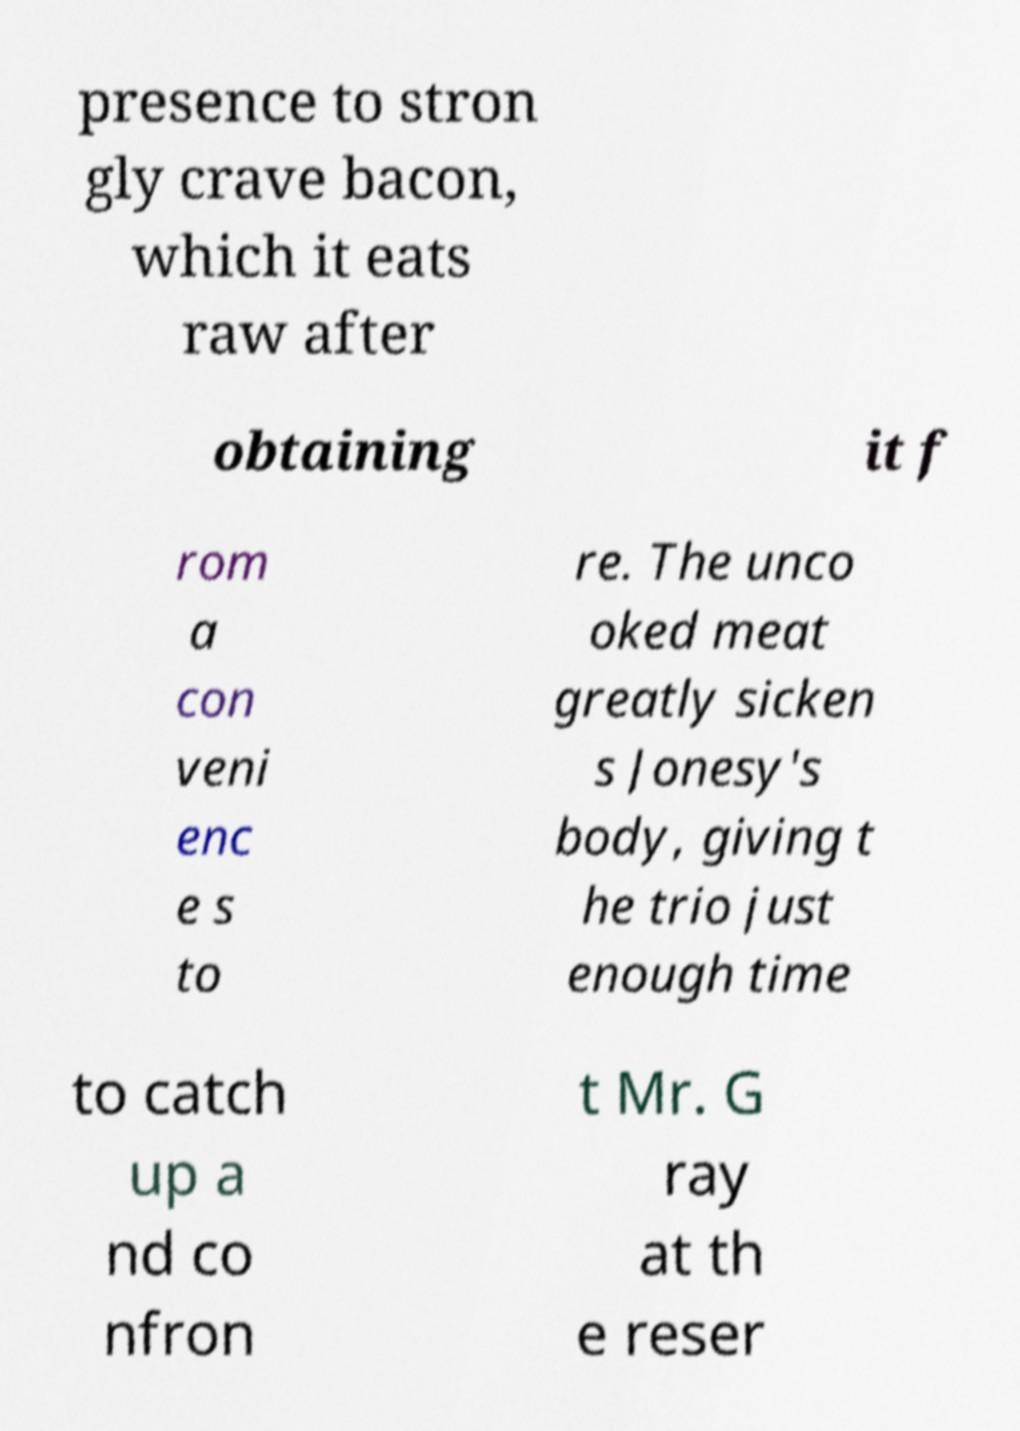Please identify and transcribe the text found in this image. presence to stron gly crave bacon, which it eats raw after obtaining it f rom a con veni enc e s to re. The unco oked meat greatly sicken s Jonesy's body, giving t he trio just enough time to catch up a nd co nfron t Mr. G ray at th e reser 